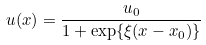Convert formula to latex. <formula><loc_0><loc_0><loc_500><loc_500>u ( x ) = \frac { u _ { 0 } } { 1 + \exp \{ \xi ( x - x _ { 0 } ) \} }</formula> 